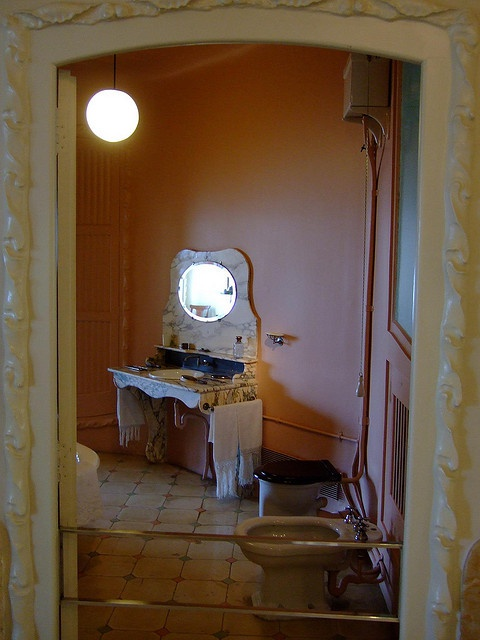Describe the objects in this image and their specific colors. I can see toilet in olive, black, maroon, and gray tones, toilet in olive, black, gray, and maroon tones, sink in olive, gray, and darkgray tones, and bottle in olive, gray, and black tones in this image. 